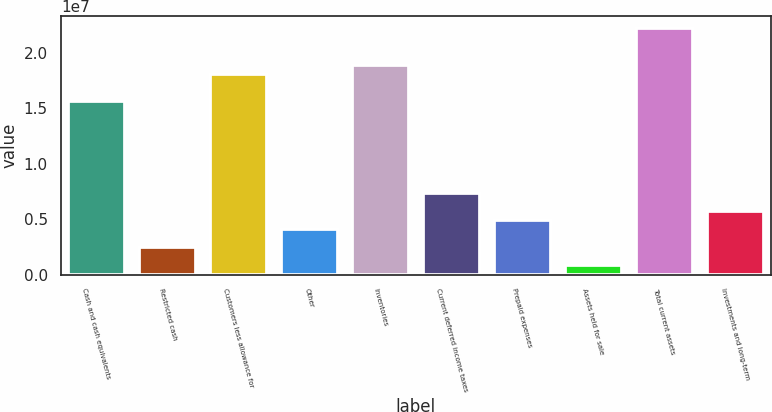Convert chart. <chart><loc_0><loc_0><loc_500><loc_500><bar_chart><fcel>Cash and cash equivalents<fcel>Restricted cash<fcel>Customers less allowance for<fcel>Other<fcel>Inventories<fcel>Current deferred income taxes<fcel>Prepaid expenses<fcel>Assets held for sale<fcel>Total current assets<fcel>Investments and long-term<nl><fcel>1.56357e+07<fcel>2.4688e+06<fcel>1.81045e+07<fcel>4.11466e+06<fcel>1.89274e+07<fcel>7.40638e+06<fcel>4.93759e+06<fcel>822934<fcel>2.22191e+07<fcel>5.76052e+06<nl></chart> 